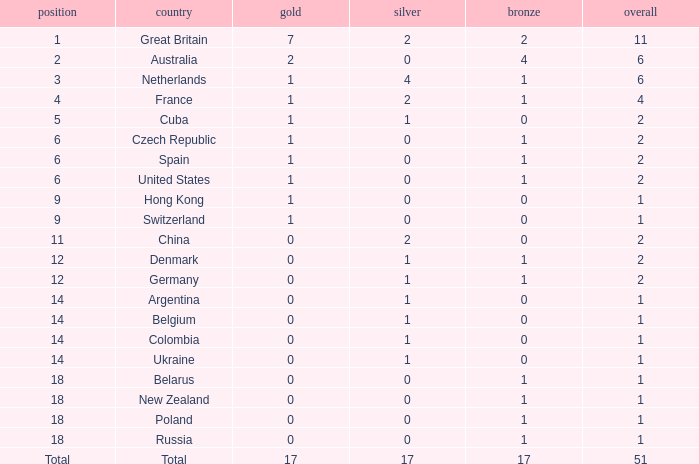Tell me the rank for bronze less than 17 and gold less than 1 11.0. 